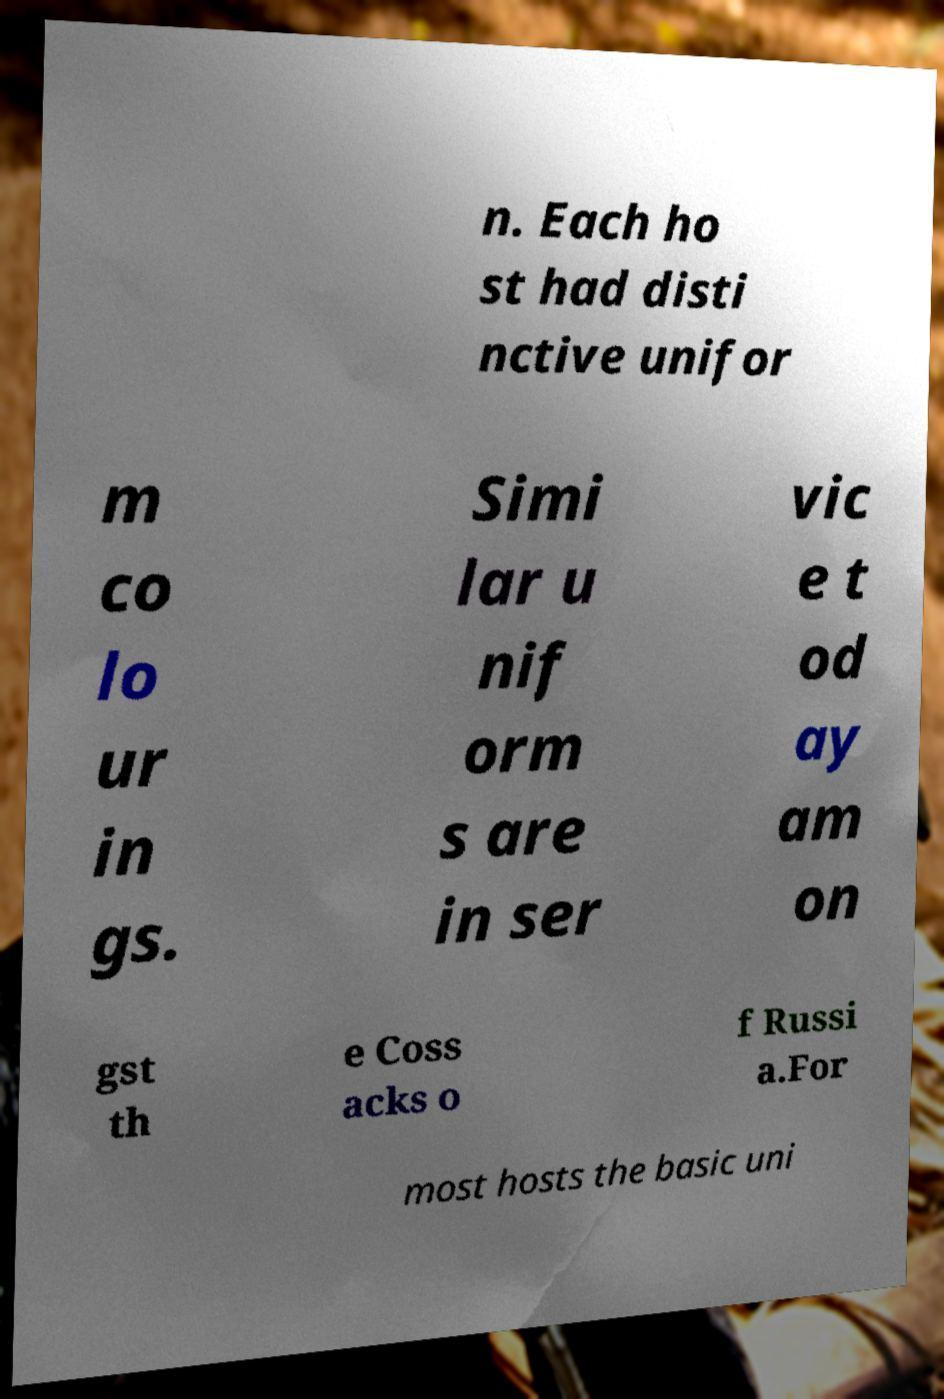Can you read and provide the text displayed in the image?This photo seems to have some interesting text. Can you extract and type it out for me? n. Each ho st had disti nctive unifor m co lo ur in gs. Simi lar u nif orm s are in ser vic e t od ay am on gst th e Coss acks o f Russi a.For most hosts the basic uni 